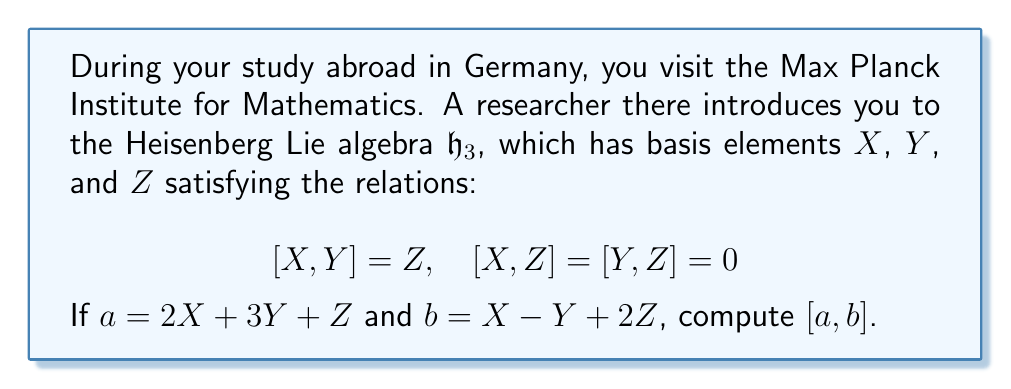Teach me how to tackle this problem. Let's approach this step-by-step:

1) The commutator $[a,b]$ is defined as $[a,b] = ab - ba$.

2) Expand $a$ and $b$:
   $a = 2X + 3Y + Z$
   $b = X - Y + 2Z$

3) To compute $[a,b]$, we need to use the linearity of the commutator and the given relations:

   $[a,b] = [2X + 3Y + Z, X - Y + 2Z]$

4) Using the linearity property:
   $[a,b] = 2[X,X] - 2[X,Y] + 4[X,Z] + 3[Y,X] - 3[Y,Y] + 6[Y,Z] + [Z,X] - [Z,Y] + 2[Z,Z]$

5) Simplify using the given relations and properties of commutators:
   - $[X,X] = [Y,Y] = [Z,Z] = 0$ (self-commutators are always zero)
   - $[X,Y] = Z$
   - $[Y,X] = -[X,Y] = -Z$
   - $[X,Z] = [Y,Z] = [Z,X] = [Z,Y] = 0$

6) After simplification:
   $[a,b] = -2Z - 3(-Z) = -2Z + 3Z = Z$

Therefore, $[a,b] = Z$.
Answer: $Z$ 